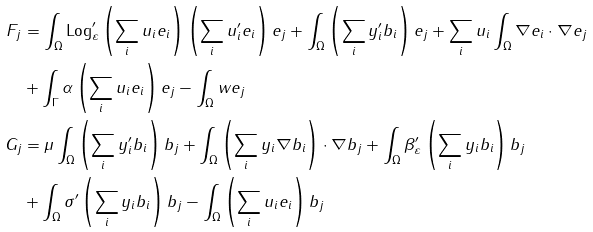Convert formula to latex. <formula><loc_0><loc_0><loc_500><loc_500>F _ { j } & = \int _ { \Omega } { \text {Log} ^ { \prime } _ { \varepsilon } \left ( \sum _ { i } { u _ { i } e _ { i } } \right ) \left ( \sum _ { i } { u ^ { \prime } _ { i } e _ { i } } \right ) e _ { j } } + \int _ { \Omega } { \left ( \sum _ { i } { y ^ { \prime } _ { i } b _ { i } } \right ) e _ { j } } + \sum _ { i } u _ { i } \int _ { \Omega } { \nabla e _ { i } \cdot \nabla e _ { j } } \\ & + \int _ { \Gamma } { \alpha \left ( \sum _ { i } { u _ { i } e _ { i } } \right ) e _ { j } } - \int _ { \Omega } { w e _ { j } } \\ G _ { j } & = \mu \int _ { \Omega } { \left ( \sum _ { i } { y ^ { \prime } _ { i } b _ { i } } \right ) b _ { j } } + \int _ { \Omega } { \left ( \sum _ { i } { y _ { i } \nabla b _ { i } } \right ) \cdot \nabla b _ { j } } + \int _ { \Omega } { \beta ^ { \prime } _ { \varepsilon } \left ( \sum _ { i } { y _ { i } b _ { i } } \right ) b _ { j } } \\ & + \int _ { \Omega } { \sigma ^ { \prime } \left ( \sum _ { i } { y _ { i } b _ { i } } \right ) b _ { j } } - \int _ { \Omega } { \left ( \sum _ { i } { u _ { i } e _ { i } } \right ) b _ { j } }</formula> 